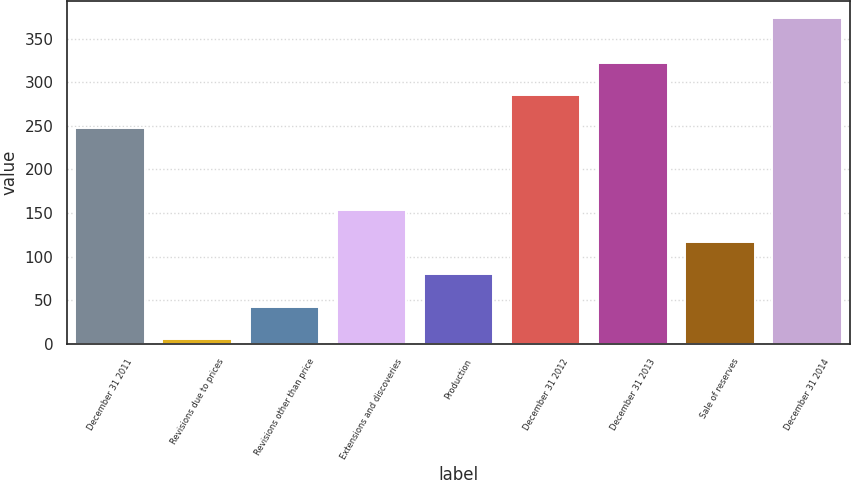<chart> <loc_0><loc_0><loc_500><loc_500><bar_chart><fcel>December 31 2011<fcel>Revisions due to prices<fcel>Revisions other than price<fcel>Extensions and discoveries<fcel>Production<fcel>December 31 2012<fcel>December 31 2013<fcel>Sale of reserves<fcel>December 31 2014<nl><fcel>248<fcel>6<fcel>42.8<fcel>153.2<fcel>79.6<fcel>284.8<fcel>321.6<fcel>116.4<fcel>374<nl></chart> 